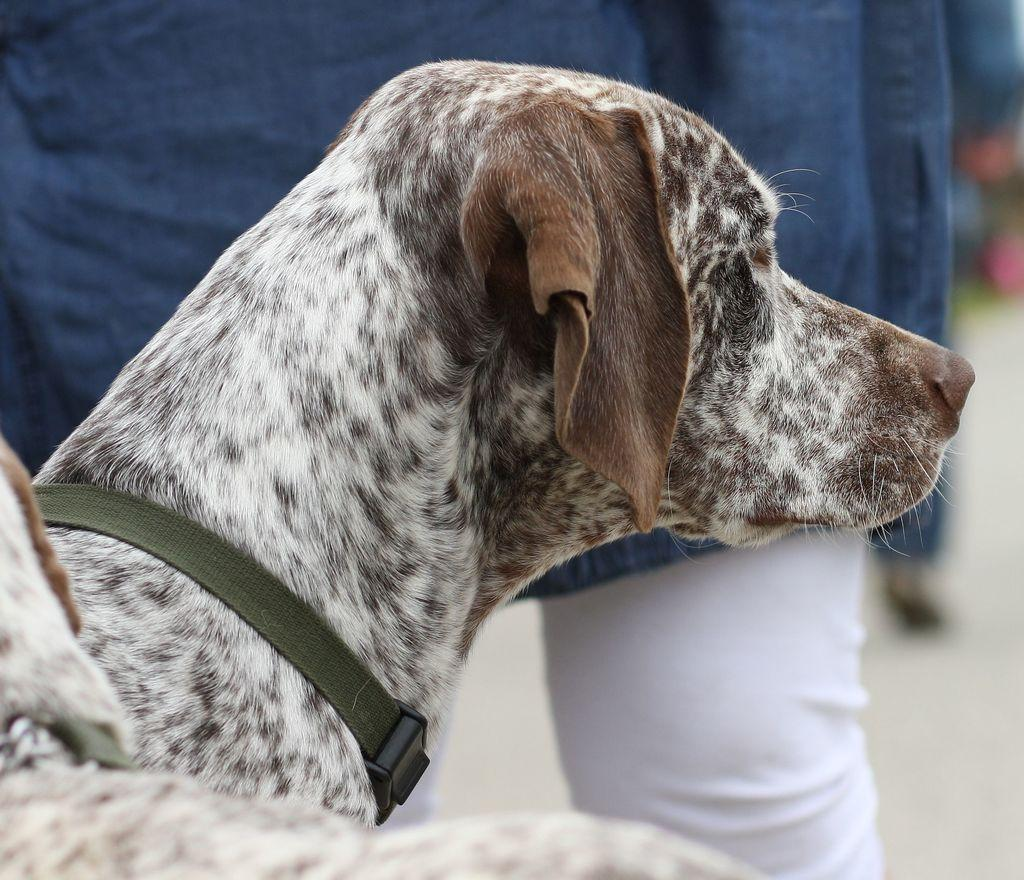What type of animal is present in the image besides the human? There are two dogs in the image. Can you describe the appearance of the dogs? The dogs are white and brown in color. What is around the necks of the dogs? The dogs have a belt around their necks. What type of celery is being exchanged between the human and the dogs in the image? There is no celery present in the image, nor is there any exchange taking place between the human and the dogs. 